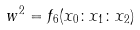<formula> <loc_0><loc_0><loc_500><loc_500>w ^ { 2 } = f _ { 6 } ( x _ { 0 } \colon x _ { 1 } \colon x _ { 2 } )</formula> 